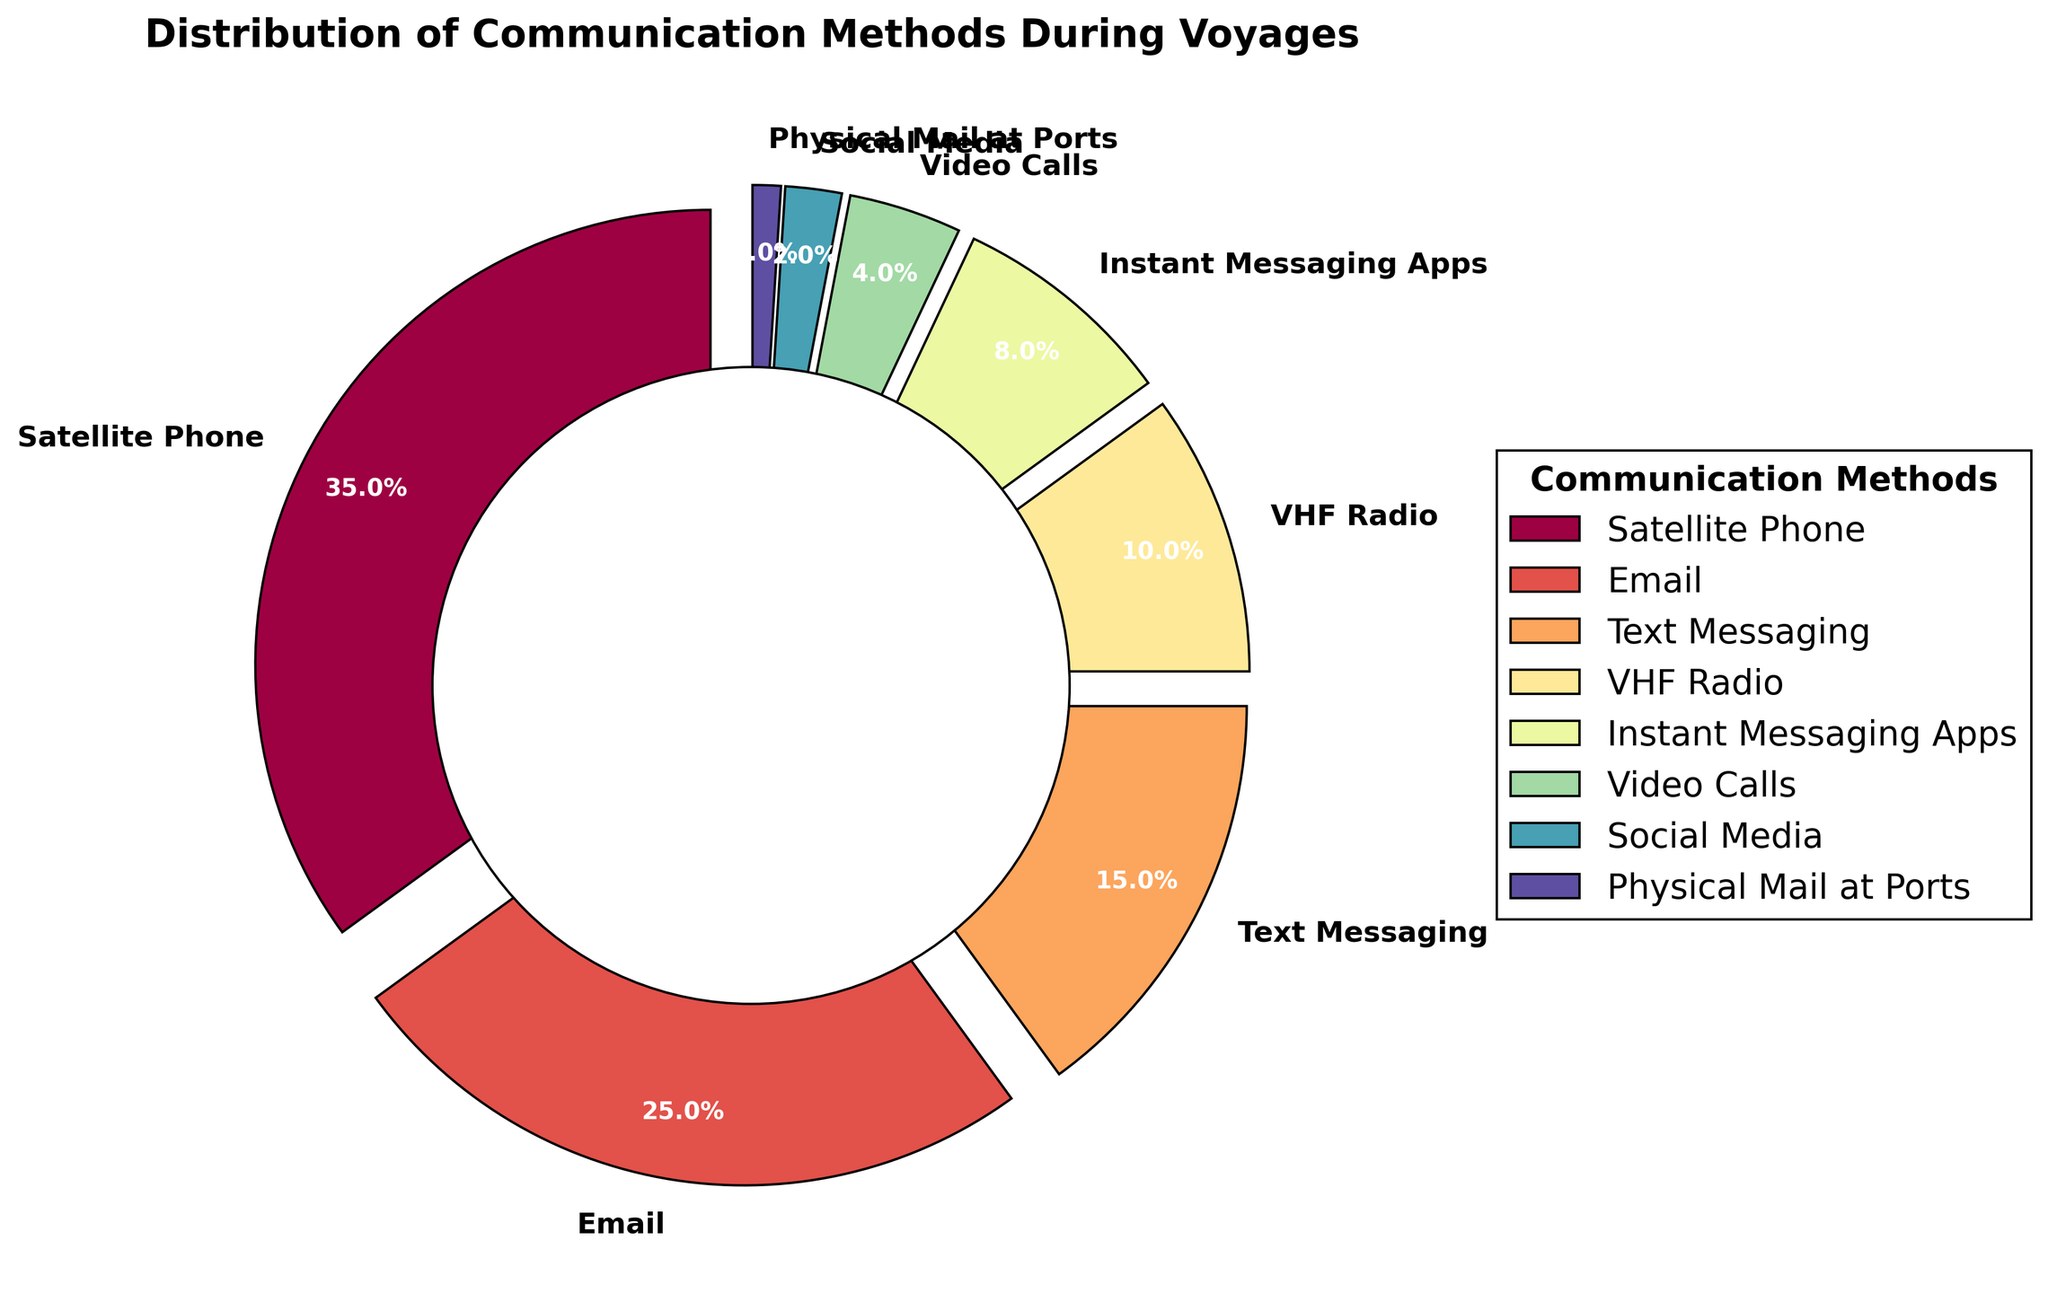Which communication method is used the most during voyages? The largest segment in the pie chart corresponds to Satellite Phone, which occupies 35% of the chart.
Answer: Satellite Phone What percentage of communication methods collectively make up more than half of the usage? Adding the percentages of Satellite Phone (35%), Email (25%), and Text Messaging (15%) gives a total of 75%, which is more than half of the usage.
Answer: 75% How many communication methods have a usage percentage below 10%? By inspecting the pie chart, VHF Radio, Instant Messaging Apps, Video Calls, Social Media, and Physical Mail at Ports are below 10%. There are 5 such methods.
Answer: 5 Compare the usage of Email and Text Messaging. Which one is used more and by what percentage? Email takes up 25% of the chart, while Text Messaging takes up 15%. Email is used 10% more than Text Messaging.
Answer: Email by 10% What is the combined percentage of usage for Video Calls and Social Media? Adding the percentages of Video Calls (4%) and Social Media (2%) gives a total of 6%.
Answer: 6% Which two communication methods have the smallest usage, and what are their combined percentage? Social Media (2%) and Physical Mail at Ports (1%) are the smallest. Their combined percentage is 2% + 1% = 3%.
Answer: 3% What percentage of communication methods used during voyages is not based on digital technology? The non-digital communication method is Physical Mail at Ports which is 1%.
Answer: 1% If we doubled the usage of Text Messaging, how would it compare to the usage of Satellite Phone? Doubling Text Messaging's 15% gives 30%. Satellite Phone's usage is 35%, so it would still be higher by 5%.
Answer: Satellite Phone by 5% Identify the segment with the darkest color and state its associated communication method and usage percentage. The segment with the darkest color in the Spectral colormap typically represents the highest percentage, which belongs to Satellite Phone at 35%.
Answer: Satellite Phone, 35% What is the difference in percentage between the most and the least used communication methods? The most used method is Satellite Phone at 35%, and the least used is Physical Mail at Ports at 1%. The difference is 35% - 1% = 34%.
Answer: 34% 